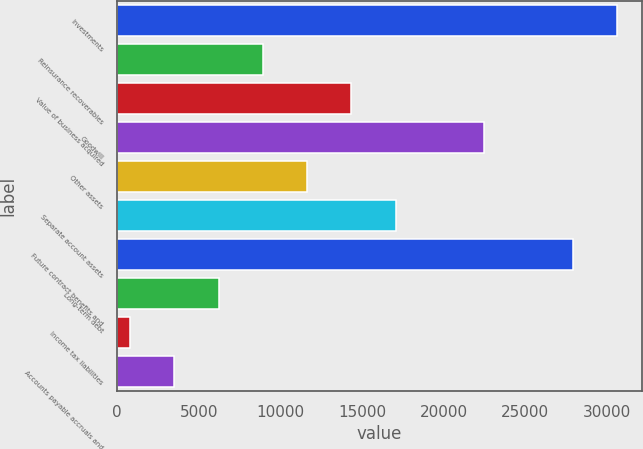Convert chart to OTSL. <chart><loc_0><loc_0><loc_500><loc_500><bar_chart><fcel>Investments<fcel>Reinsurance recoverables<fcel>Value of business acquired<fcel>Goodwill<fcel>Other assets<fcel>Separate account assets<fcel>Future contract benefits and<fcel>Long-term debt<fcel>Income tax liabilities<fcel>Accounts payable accruals and<nl><fcel>30622.8<fcel>8920.4<fcel>14346<fcel>22484.4<fcel>11633.2<fcel>17058.8<fcel>27910<fcel>6207.6<fcel>782<fcel>3494.8<nl></chart> 